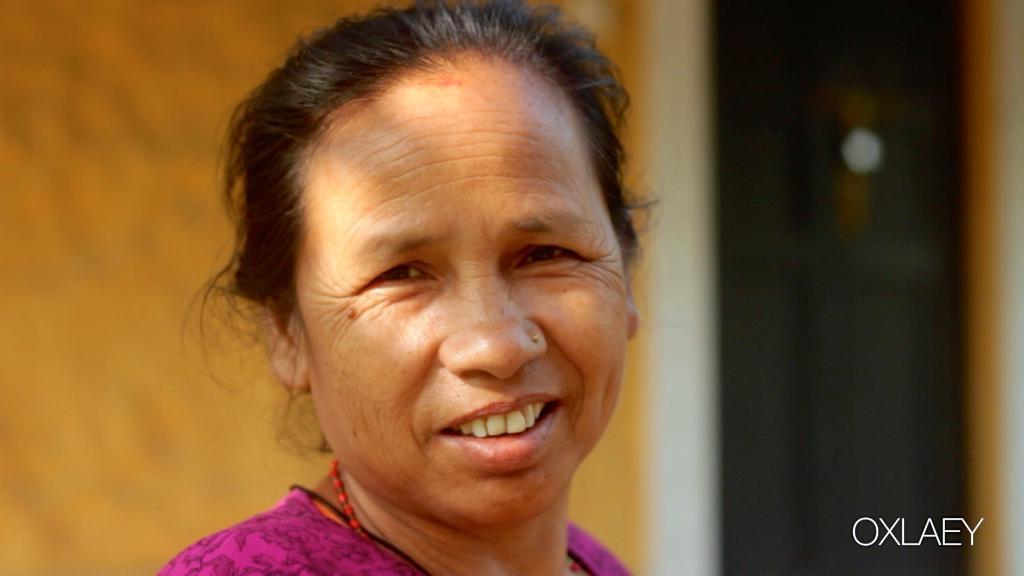Please provide a concise description of this image. In the middle of the image we can see a woman and a wall in the background. 